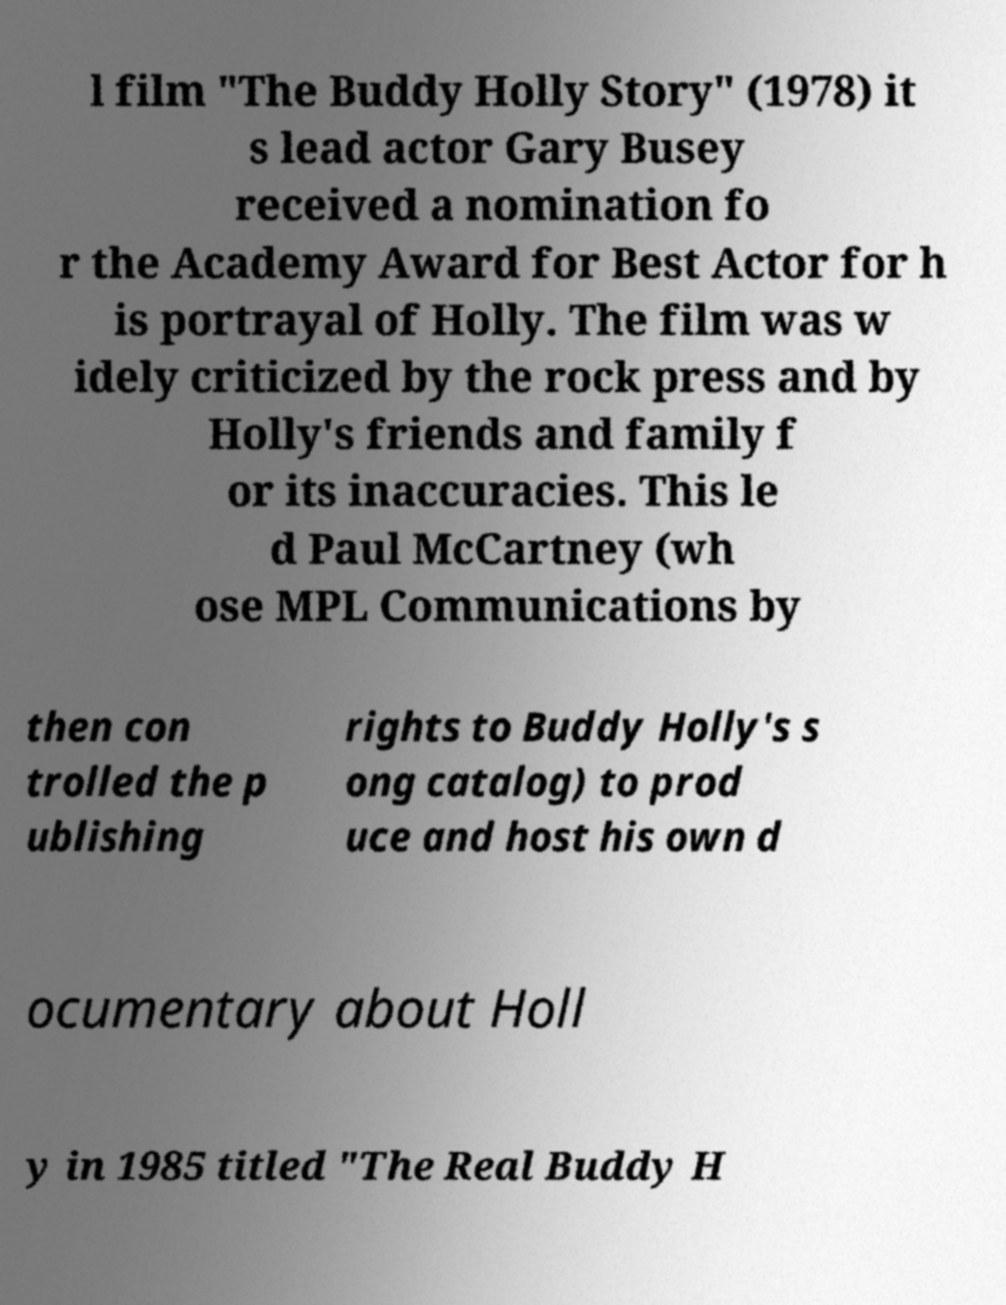Can you read and provide the text displayed in the image?This photo seems to have some interesting text. Can you extract and type it out for me? l film "The Buddy Holly Story" (1978) it s lead actor Gary Busey received a nomination fo r the Academy Award for Best Actor for h is portrayal of Holly. The film was w idely criticized by the rock press and by Holly's friends and family f or its inaccuracies. This le d Paul McCartney (wh ose MPL Communications by then con trolled the p ublishing rights to Buddy Holly's s ong catalog) to prod uce and host his own d ocumentary about Holl y in 1985 titled "The Real Buddy H 